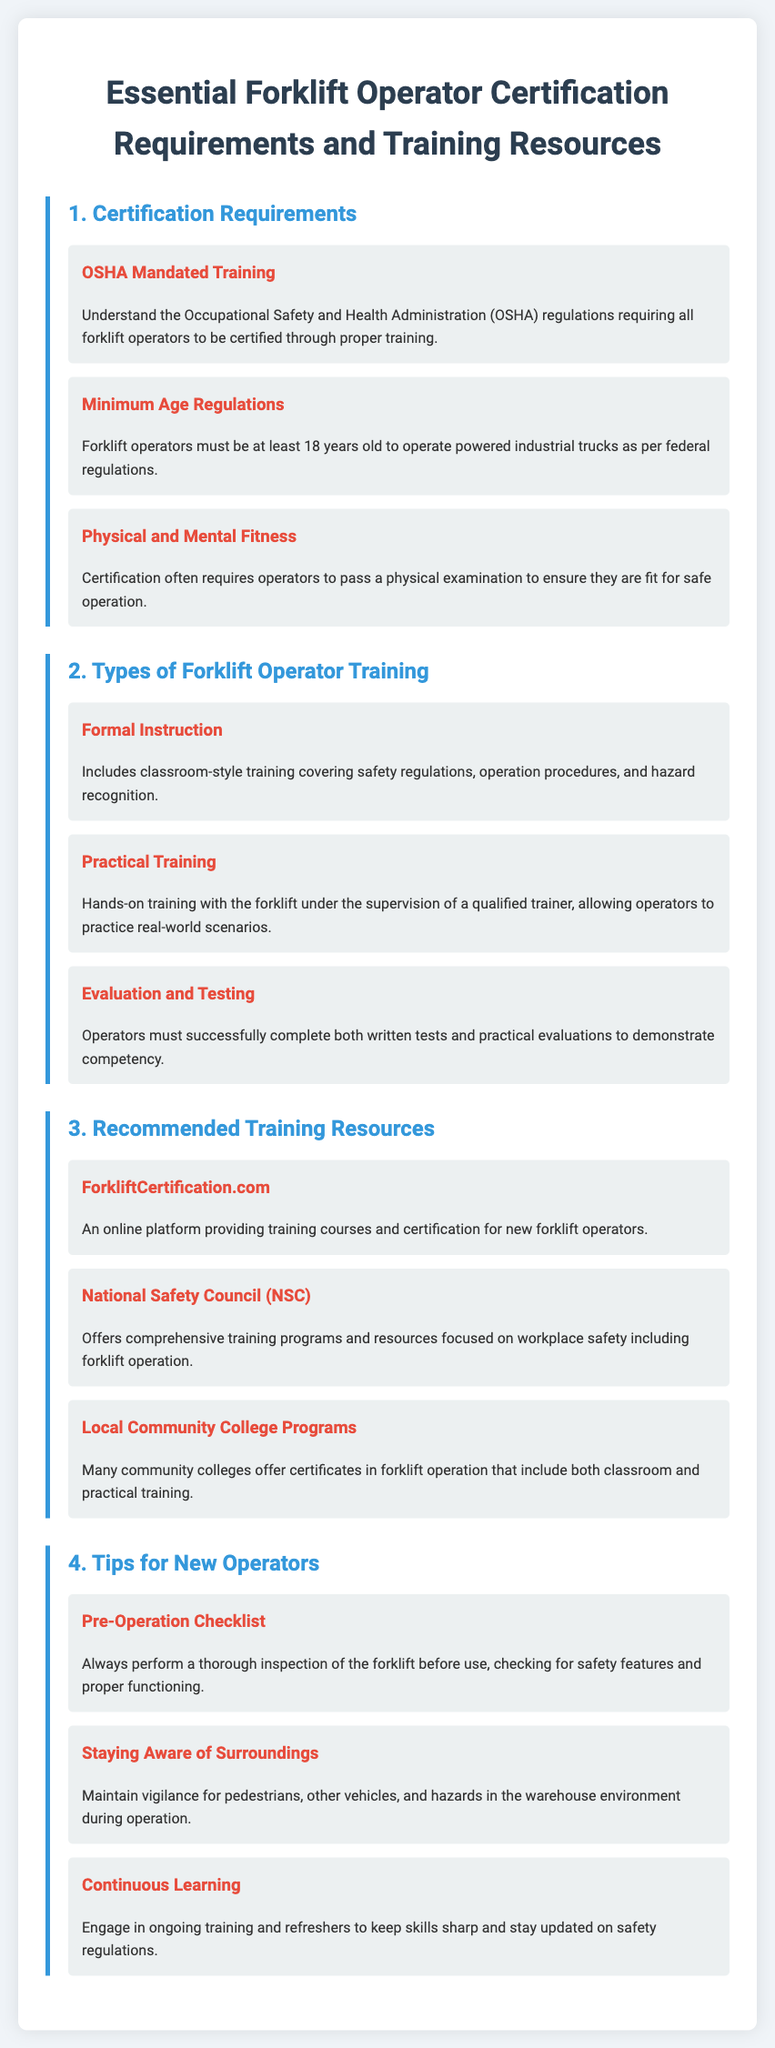What is the age requirement to operate a forklift? The document states that forklift operators must be at least 18 years old to operate powered industrial trucks as per federal regulations.
Answer: 18 years old What type of training includes classroom instruction? This training refers to 'Formal Instruction', which covers safety regulations, operation procedures, and hazard recognition.
Answer: Formal Instruction Which organization offers courses for new forklift operators? The document mentions ForkliftCertification.com as an online platform providing training courses for new forklift operators.
Answer: ForkliftCertification.com What should operators perform before using a forklift? Operators are advised to perform a thorough inspection of the forklift checking for safety features and proper functioning.
Answer: Pre-Operation Checklist What is required to demonstrate competency in forklift operation? Operators must complete both written tests and practical evaluations successfully to demonstrate competency.
Answer: Evaluation and Testing What is emphasized for maintaining safety while operating a forklift? Operators should stay aware of surroundings, including pedestrians, other vehicles, and hazards in the warehouse environment.
Answer: Staying Aware of Surroundings Which training program focuses on workplace safety? The National Safety Council (NSC) offers comprehensive training programs and resources focused on workplace safety, including forklift operation.
Answer: National Safety Council (NSC) 